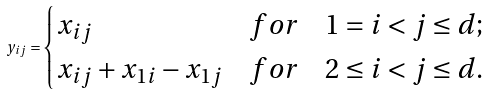Convert formula to latex. <formula><loc_0><loc_0><loc_500><loc_500>y _ { i j } = \begin{cases} x _ { i j } & f o r \quad 1 = i < j \leq d ; \\ x _ { i j } + x _ { 1 i } - x _ { 1 j } & f o r \quad 2 \leq i < j \leq d . \end{cases}</formula> 